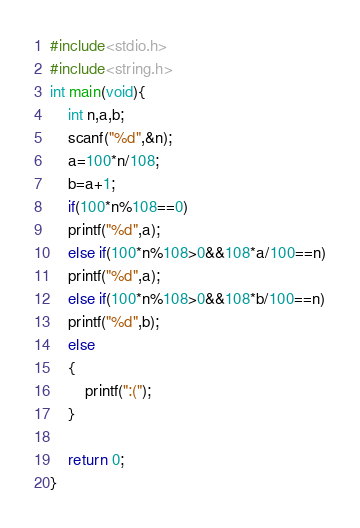<code> <loc_0><loc_0><loc_500><loc_500><_C_>#include<stdio.h>
#include<string.h>
int main(void){ 
    int n,a,b;
    scanf("%d",&n);
    a=100*n/108;
    b=a+1;
    if(100*n%108==0)
    printf("%d",a);
    else if(100*n%108>0&&108*a/100==n)
    printf("%d",a);
    else if(100*n%108>0&&108*b/100==n)
    printf("%d",b);
    else
    {
        printf(":(");
    }
    
    return 0;
}</code> 